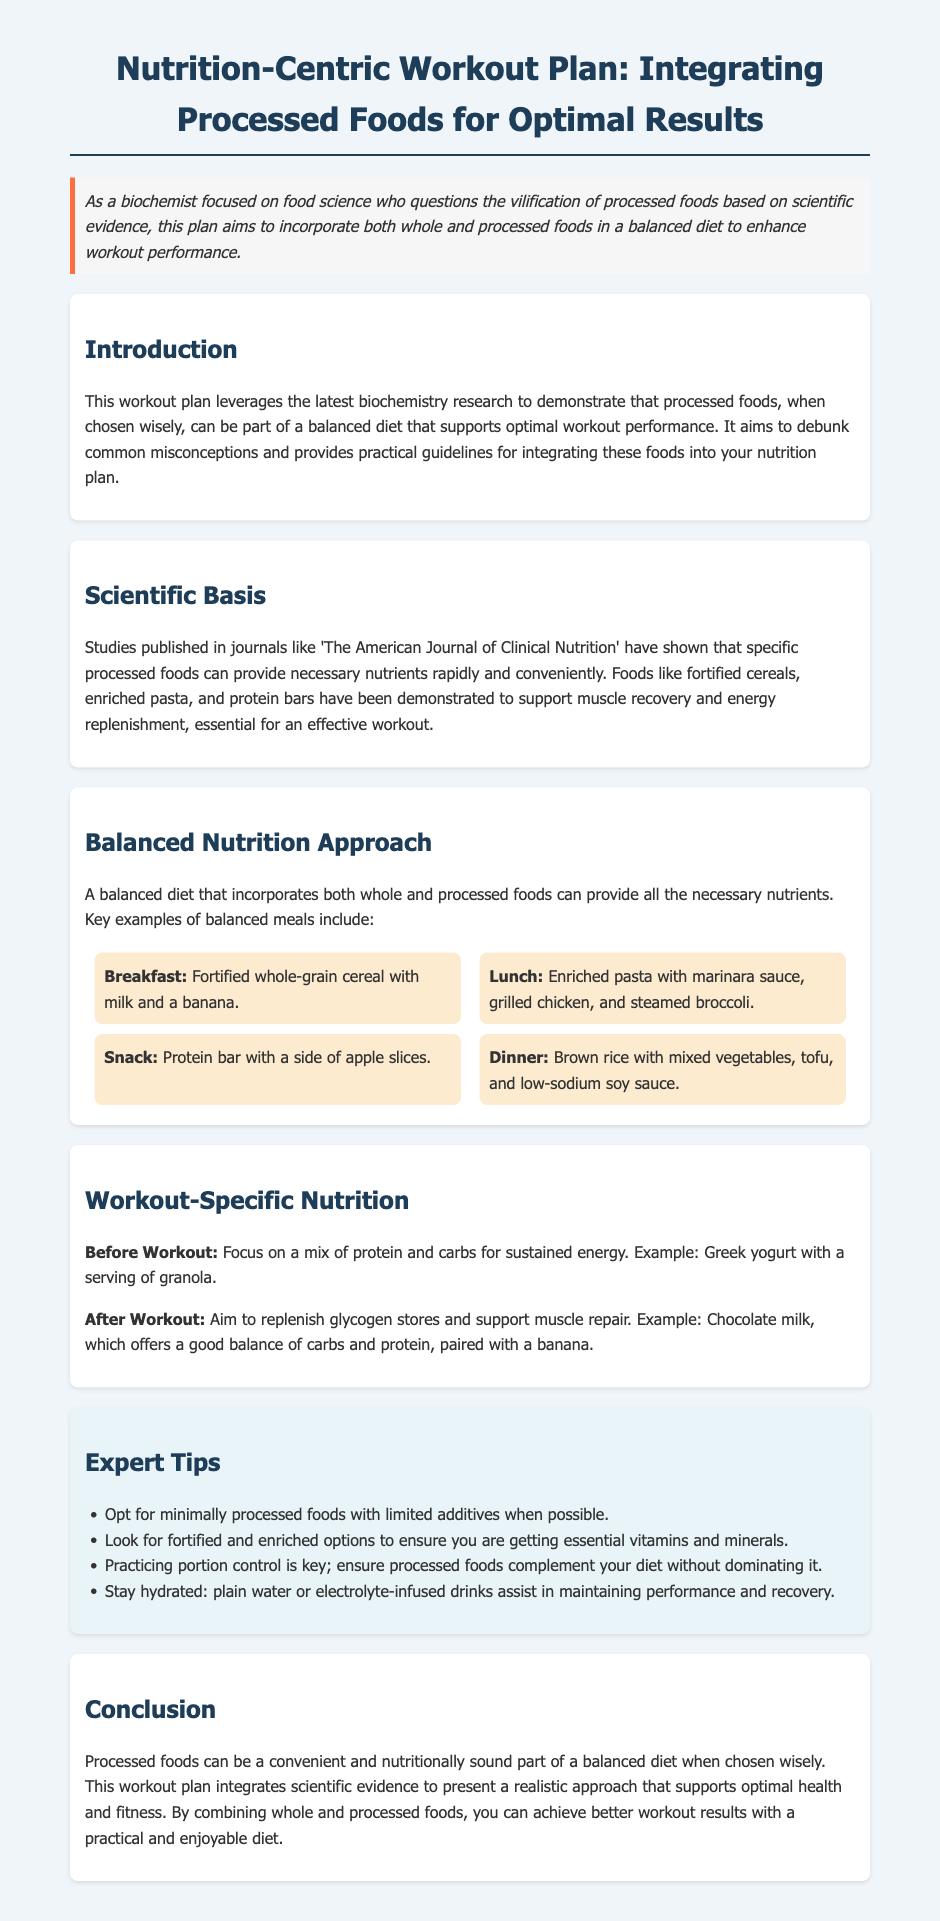What is the main focus of the workout plan? The main focus of the workout plan is to integrate processed foods into a balanced diet to enhance workout performance.
Answer: Integrate processed foods What type of meals are suggested for breakfast in the balanced diet section? The breakfast meal suggested is fortified whole-grain cereal with milk and a banana.
Answer: Fortified whole-grain cereal with milk and a banana Which food is recommended after a workout for replenishing glycogen stores? The document recommends chocolate milk after a workout to replenish glycogen stores and support muscle repair.
Answer: Chocolate milk What nutrients does the plan emphasize before a workout? The plan emphasizes a mix of protein and carbs for sustained energy before a workout.
Answer: Protein and carbs Which expert tip advises regarding additives in processed foods? One expert tip advises opting for minimally processed foods with limited additives when possible.
Answer: Minimally processed foods What type of foods should complement the diet without dominating it? Processed foods should complement the diet without dominating it.
Answer: Processed foods What type of foods are advised to look for to ensure essential vitamins and minerals? The document advises looking for fortified and enriched options to ensure essential vitamins and minerals.
Answer: Fortified and enriched options Which publication is mentioned for supporting the scientific basis? 'The American Journal of Clinical Nutrition' is mentioned as supporting the scientific basis.
Answer: The American Journal of Clinical Nutrition What is emphasized for hydration during workouts? Staying hydrated with plain water or electrolyte-infused drinks is emphasized for hydration during workouts.
Answer: Plain water or electrolyte-infused drinks 